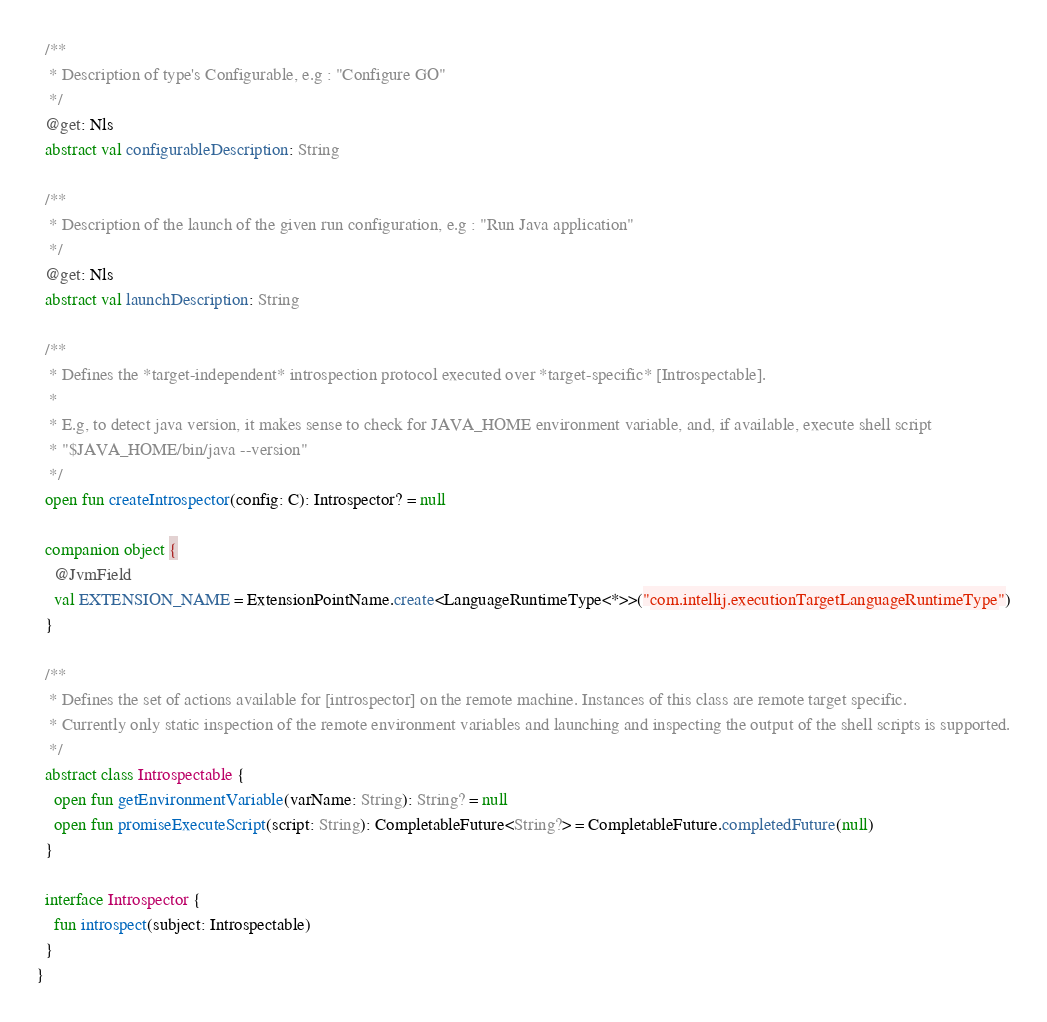<code> <loc_0><loc_0><loc_500><loc_500><_Kotlin_>
  /**
   * Description of type's Configurable, e.g : "Configure GO"
   */
  @get: Nls
  abstract val configurableDescription: String

  /**
   * Description of the launch of the given run configuration, e.g : "Run Java application"
   */
  @get: Nls
  abstract val launchDescription: String

  /**
   * Defines the *target-independent* introspection protocol executed over *target-specific* [Introspectable].
   *
   * E.g, to detect java version, it makes sense to check for JAVA_HOME environment variable, and, if available, execute shell script
   * "$JAVA_HOME/bin/java --version"
   */
  open fun createIntrospector(config: C): Introspector? = null

  companion object {
    @JvmField
    val EXTENSION_NAME = ExtensionPointName.create<LanguageRuntimeType<*>>("com.intellij.executionTargetLanguageRuntimeType")
  }

  /**
   * Defines the set of actions available for [introspector] on the remote machine. Instances of this class are remote target specific.
   * Currently only static inspection of the remote environment variables and launching and inspecting the output of the shell scripts is supported.
   */
  abstract class Introspectable {
    open fun getEnvironmentVariable(varName: String): String? = null
    open fun promiseExecuteScript(script: String): CompletableFuture<String?> = CompletableFuture.completedFuture(null)
  }

  interface Introspector {
    fun introspect(subject: Introspectable)
  }
}
</code> 